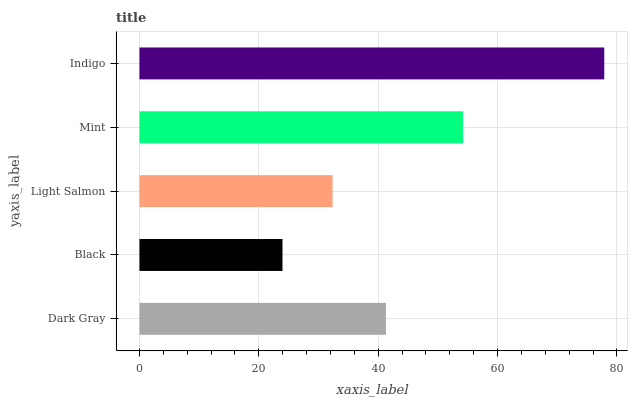Is Black the minimum?
Answer yes or no. Yes. Is Indigo the maximum?
Answer yes or no. Yes. Is Light Salmon the minimum?
Answer yes or no. No. Is Light Salmon the maximum?
Answer yes or no. No. Is Light Salmon greater than Black?
Answer yes or no. Yes. Is Black less than Light Salmon?
Answer yes or no. Yes. Is Black greater than Light Salmon?
Answer yes or no. No. Is Light Salmon less than Black?
Answer yes or no. No. Is Dark Gray the high median?
Answer yes or no. Yes. Is Dark Gray the low median?
Answer yes or no. Yes. Is Light Salmon the high median?
Answer yes or no. No. Is Black the low median?
Answer yes or no. No. 